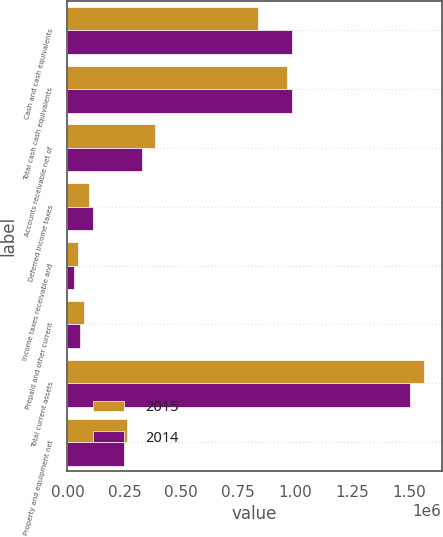Convert chart to OTSL. <chart><loc_0><loc_0><loc_500><loc_500><stacked_bar_chart><ecel><fcel>Cash and cash equivalents<fcel>Total cash cash equivalents<fcel>Accounts receivable net of<fcel>Deferred income taxes<fcel>Income taxes receivable and<fcel>Prepaid and other current<fcel>Total current assets<fcel>Property and equipment net<nl><fcel>2015<fcel>836188<fcel>964935<fcel>385694<fcel>94994<fcel>46732<fcel>71446<fcel>1.5638e+06<fcel>263077<nl><fcel>2014<fcel>985762<fcel>985762<fcel>326727<fcel>111449<fcel>26496<fcel>54301<fcel>1.50474e+06<fcel>249098<nl></chart> 